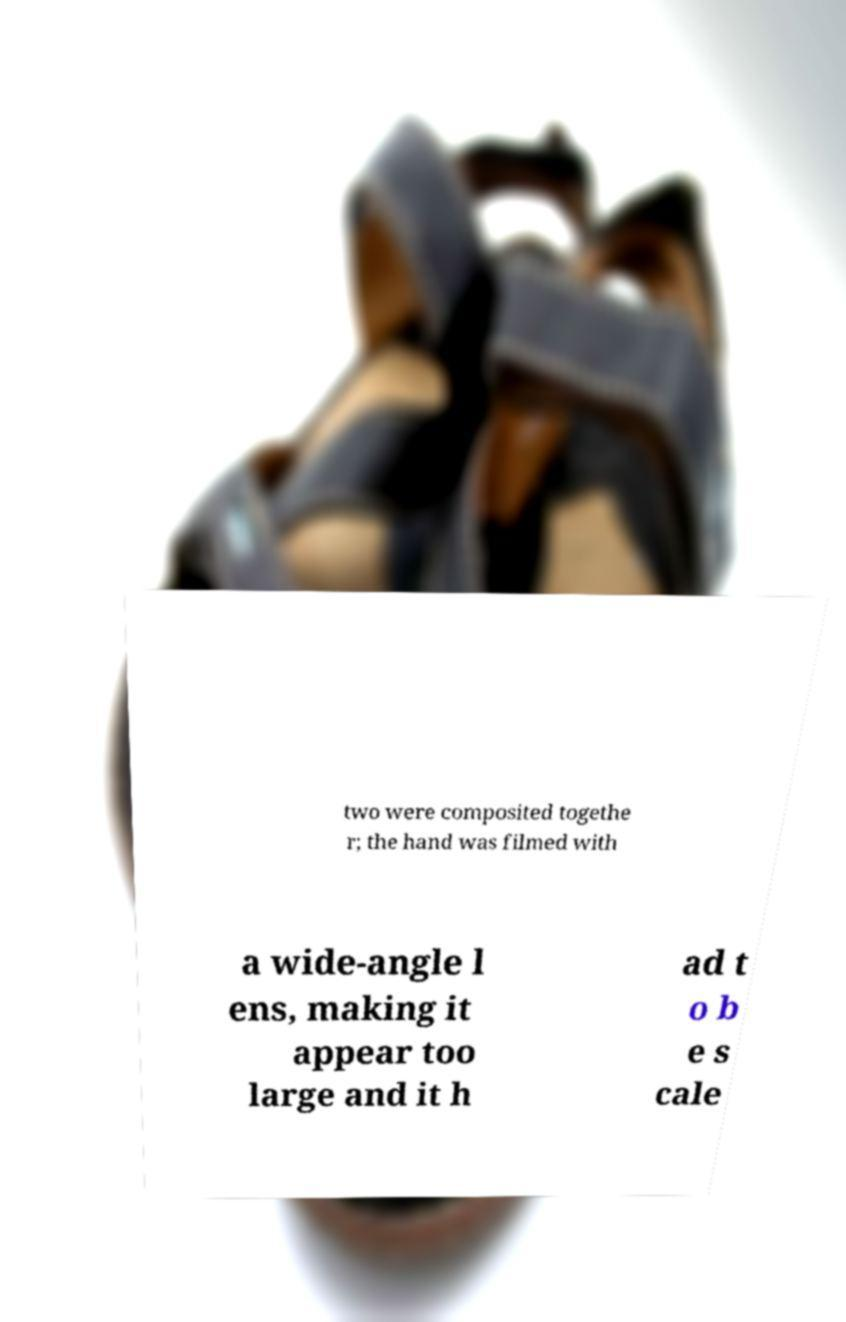Please identify and transcribe the text found in this image. two were composited togethe r; the hand was filmed with a wide-angle l ens, making it appear too large and it h ad t o b e s cale 